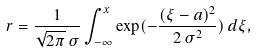<formula> <loc_0><loc_0><loc_500><loc_500>r = \frac { 1 } { \sqrt { 2 \pi } \, \sigma } \int _ { - \infty } ^ { x } \exp ( - \frac { ( \xi - a ) ^ { 2 } } { 2 \, \sigma ^ { 2 } } ) \, { d } \xi ,</formula> 